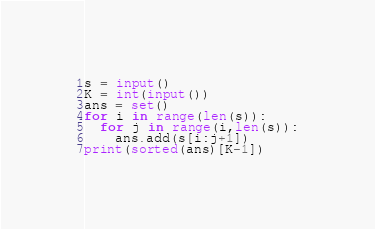Convert code to text. <code><loc_0><loc_0><loc_500><loc_500><_Python_>s = input()
K = int(input())
ans = set()
for i in range(len(s)):
  for j in range(i,len(s)):
    ans.add(s[i:j+1])
print(sorted(ans)[K-1])</code> 